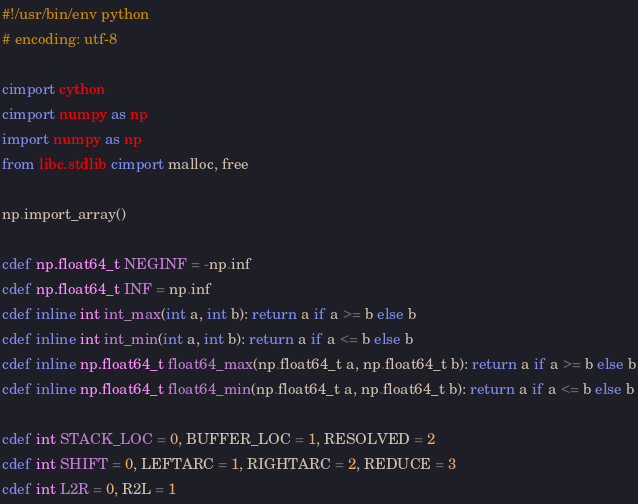<code> <loc_0><loc_0><loc_500><loc_500><_Cython_>#!/usr/bin/env python
# encoding: utf-8

cimport cython
cimport numpy as np
import numpy as np
from libc.stdlib cimport malloc, free

np.import_array()

cdef np.float64_t NEGINF = -np.inf
cdef np.float64_t INF = np.inf
cdef inline int int_max(int a, int b): return a if a >= b else b
cdef inline int int_min(int a, int b): return a if a <= b else b
cdef inline np.float64_t float64_max(np.float64_t a, np.float64_t b): return a if a >= b else b
cdef inline np.float64_t float64_min(np.float64_t a, np.float64_t b): return a if a <= b else b

cdef int STACK_LOC = 0, BUFFER_LOC = 1, RESOLVED = 2
cdef int SHIFT = 0, LEFTARC = 1, RIGHTARC = 2, REDUCE = 3
cdef int L2R = 0, R2L = 1

</code> 